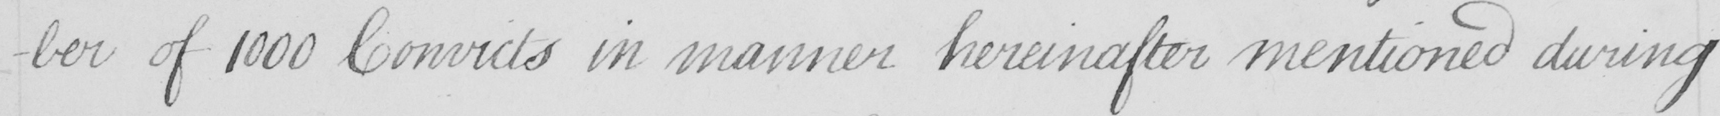What does this handwritten line say? -ber of 1000 Convicts in manner hereinafter mentioned during 